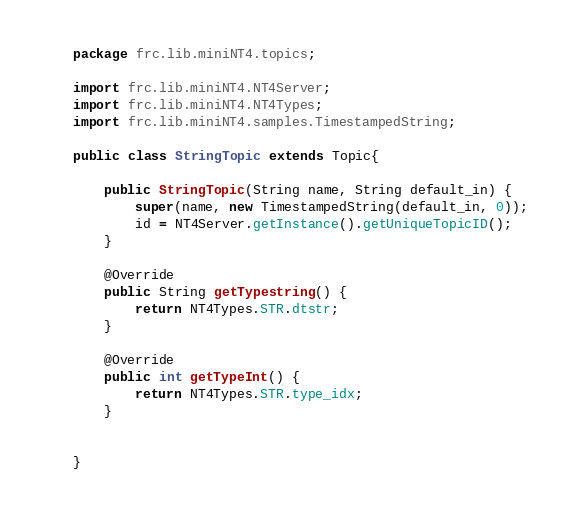Convert code to text. <code><loc_0><loc_0><loc_500><loc_500><_Java_>package frc.lib.miniNT4.topics;

import frc.lib.miniNT4.NT4Server;
import frc.lib.miniNT4.NT4Types;
import frc.lib.miniNT4.samples.TimestampedString;

public class StringTopic extends Topic{

    public StringTopic(String name, String default_in) {
        super(name, new TimestampedString(default_in, 0));
        id = NT4Server.getInstance().getUniqueTopicID();
    }

    @Override
    public String getTypestring() {
        return NT4Types.STR.dtstr;
    }

    @Override
    public int getTypeInt() {
        return NT4Types.STR.type_idx;
    }

    
}
</code> 